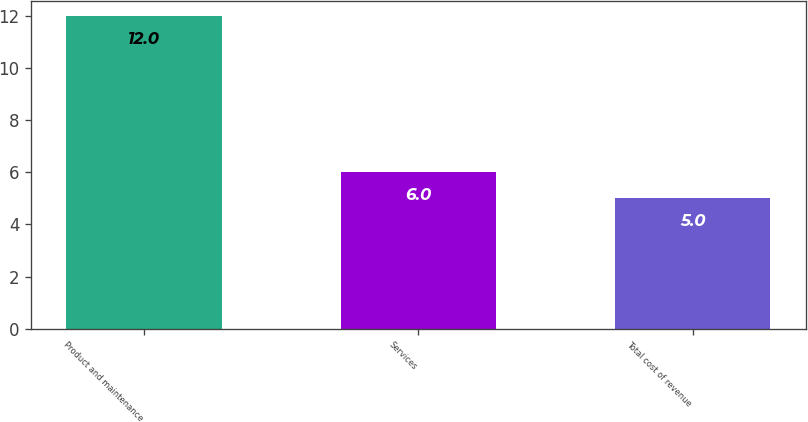Convert chart to OTSL. <chart><loc_0><loc_0><loc_500><loc_500><bar_chart><fcel>Product and maintenance<fcel>Services<fcel>Total cost of revenue<nl><fcel>12<fcel>6<fcel>5<nl></chart> 